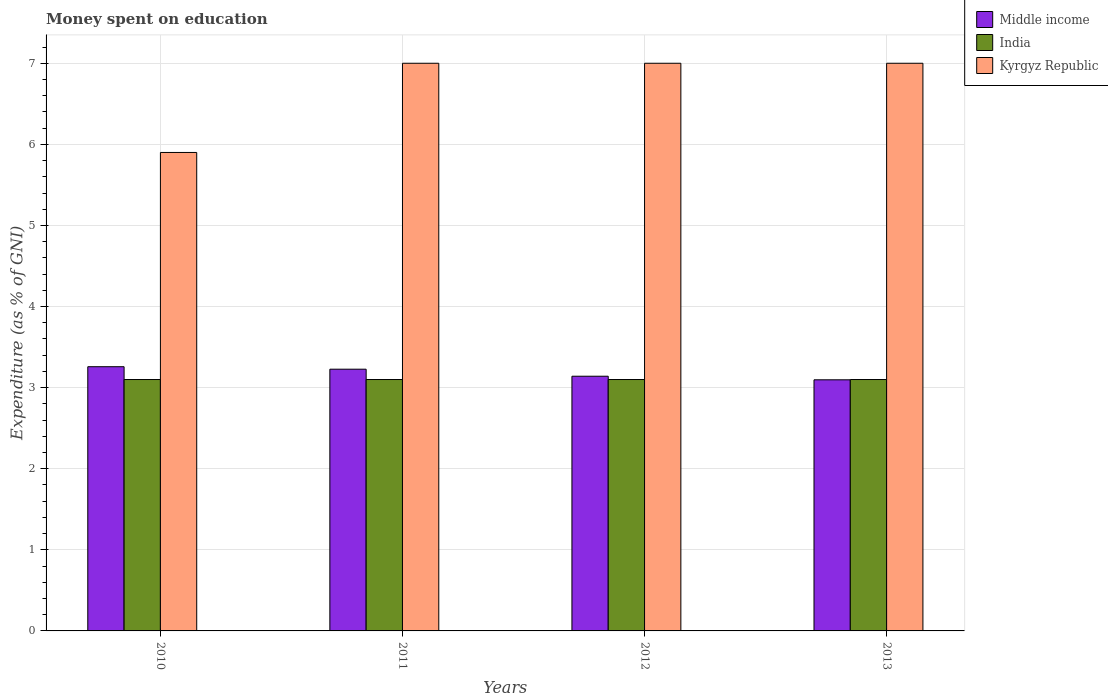How many different coloured bars are there?
Make the answer very short. 3. How many groups of bars are there?
Offer a terse response. 4. How many bars are there on the 1st tick from the right?
Ensure brevity in your answer.  3. In how many cases, is the number of bars for a given year not equal to the number of legend labels?
Offer a very short reply. 0. What is the amount of money spent on education in Middle income in 2010?
Give a very brief answer. 3.26. Across all years, what is the maximum amount of money spent on education in Middle income?
Give a very brief answer. 3.26. In which year was the amount of money spent on education in Kyrgyz Republic maximum?
Offer a very short reply. 2011. What is the total amount of money spent on education in Kyrgyz Republic in the graph?
Make the answer very short. 26.9. What is the difference between the amount of money spent on education in Middle income in 2012 and the amount of money spent on education in Kyrgyz Republic in 2013?
Keep it short and to the point. -3.86. What is the average amount of money spent on education in Middle income per year?
Provide a succinct answer. 3.18. In the year 2013, what is the difference between the amount of money spent on education in India and amount of money spent on education in Kyrgyz Republic?
Your response must be concise. -3.9. In how many years, is the amount of money spent on education in Middle income greater than 1.6 %?
Keep it short and to the point. 4. What is the ratio of the amount of money spent on education in Kyrgyz Republic in 2010 to that in 2013?
Provide a short and direct response. 0.84. What is the difference between the highest and the second highest amount of money spent on education in Kyrgyz Republic?
Keep it short and to the point. 0. What is the difference between the highest and the lowest amount of money spent on education in India?
Your answer should be very brief. 0. In how many years, is the amount of money spent on education in India greater than the average amount of money spent on education in India taken over all years?
Give a very brief answer. 0. What does the 2nd bar from the right in 2013 represents?
Make the answer very short. India. Is it the case that in every year, the sum of the amount of money spent on education in India and amount of money spent on education in Kyrgyz Republic is greater than the amount of money spent on education in Middle income?
Your answer should be very brief. Yes. How many bars are there?
Your answer should be very brief. 12. How many years are there in the graph?
Make the answer very short. 4. What is the difference between two consecutive major ticks on the Y-axis?
Offer a terse response. 1. Does the graph contain grids?
Your answer should be very brief. Yes. What is the title of the graph?
Offer a very short reply. Money spent on education. What is the label or title of the Y-axis?
Give a very brief answer. Expenditure (as % of GNI). What is the Expenditure (as % of GNI) in Middle income in 2010?
Your answer should be compact. 3.26. What is the Expenditure (as % of GNI) in Middle income in 2011?
Give a very brief answer. 3.23. What is the Expenditure (as % of GNI) in Kyrgyz Republic in 2011?
Provide a short and direct response. 7. What is the Expenditure (as % of GNI) of Middle income in 2012?
Your response must be concise. 3.14. What is the Expenditure (as % of GNI) of India in 2012?
Your response must be concise. 3.1. What is the Expenditure (as % of GNI) of Kyrgyz Republic in 2012?
Your answer should be compact. 7. What is the Expenditure (as % of GNI) in Middle income in 2013?
Keep it short and to the point. 3.1. What is the Expenditure (as % of GNI) of India in 2013?
Offer a very short reply. 3.1. What is the Expenditure (as % of GNI) of Kyrgyz Republic in 2013?
Provide a succinct answer. 7. Across all years, what is the maximum Expenditure (as % of GNI) in Middle income?
Your answer should be very brief. 3.26. Across all years, what is the maximum Expenditure (as % of GNI) of India?
Offer a terse response. 3.1. Across all years, what is the maximum Expenditure (as % of GNI) in Kyrgyz Republic?
Your response must be concise. 7. Across all years, what is the minimum Expenditure (as % of GNI) in Middle income?
Your response must be concise. 3.1. Across all years, what is the minimum Expenditure (as % of GNI) in Kyrgyz Republic?
Ensure brevity in your answer.  5.9. What is the total Expenditure (as % of GNI) in Middle income in the graph?
Ensure brevity in your answer.  12.72. What is the total Expenditure (as % of GNI) in Kyrgyz Republic in the graph?
Keep it short and to the point. 26.9. What is the difference between the Expenditure (as % of GNI) of Middle income in 2010 and that in 2011?
Provide a short and direct response. 0.03. What is the difference between the Expenditure (as % of GNI) in Middle income in 2010 and that in 2012?
Your answer should be very brief. 0.12. What is the difference between the Expenditure (as % of GNI) in India in 2010 and that in 2012?
Keep it short and to the point. 0. What is the difference between the Expenditure (as % of GNI) of Middle income in 2010 and that in 2013?
Provide a short and direct response. 0.16. What is the difference between the Expenditure (as % of GNI) of India in 2010 and that in 2013?
Give a very brief answer. 0. What is the difference between the Expenditure (as % of GNI) of Middle income in 2011 and that in 2012?
Give a very brief answer. 0.09. What is the difference between the Expenditure (as % of GNI) in India in 2011 and that in 2012?
Offer a terse response. 0. What is the difference between the Expenditure (as % of GNI) of Middle income in 2011 and that in 2013?
Your answer should be very brief. 0.13. What is the difference between the Expenditure (as % of GNI) of India in 2011 and that in 2013?
Offer a terse response. 0. What is the difference between the Expenditure (as % of GNI) of Middle income in 2012 and that in 2013?
Your answer should be very brief. 0.04. What is the difference between the Expenditure (as % of GNI) of India in 2012 and that in 2013?
Make the answer very short. 0. What is the difference between the Expenditure (as % of GNI) in Kyrgyz Republic in 2012 and that in 2013?
Offer a very short reply. 0. What is the difference between the Expenditure (as % of GNI) in Middle income in 2010 and the Expenditure (as % of GNI) in India in 2011?
Offer a terse response. 0.16. What is the difference between the Expenditure (as % of GNI) in Middle income in 2010 and the Expenditure (as % of GNI) in Kyrgyz Republic in 2011?
Your answer should be very brief. -3.74. What is the difference between the Expenditure (as % of GNI) in India in 2010 and the Expenditure (as % of GNI) in Kyrgyz Republic in 2011?
Your answer should be very brief. -3.9. What is the difference between the Expenditure (as % of GNI) of Middle income in 2010 and the Expenditure (as % of GNI) of India in 2012?
Give a very brief answer. 0.16. What is the difference between the Expenditure (as % of GNI) in Middle income in 2010 and the Expenditure (as % of GNI) in Kyrgyz Republic in 2012?
Offer a terse response. -3.74. What is the difference between the Expenditure (as % of GNI) of India in 2010 and the Expenditure (as % of GNI) of Kyrgyz Republic in 2012?
Provide a succinct answer. -3.9. What is the difference between the Expenditure (as % of GNI) of Middle income in 2010 and the Expenditure (as % of GNI) of India in 2013?
Offer a terse response. 0.16. What is the difference between the Expenditure (as % of GNI) in Middle income in 2010 and the Expenditure (as % of GNI) in Kyrgyz Republic in 2013?
Give a very brief answer. -3.74. What is the difference between the Expenditure (as % of GNI) of Middle income in 2011 and the Expenditure (as % of GNI) of India in 2012?
Your answer should be very brief. 0.13. What is the difference between the Expenditure (as % of GNI) in Middle income in 2011 and the Expenditure (as % of GNI) in Kyrgyz Republic in 2012?
Offer a very short reply. -3.77. What is the difference between the Expenditure (as % of GNI) of India in 2011 and the Expenditure (as % of GNI) of Kyrgyz Republic in 2012?
Offer a terse response. -3.9. What is the difference between the Expenditure (as % of GNI) of Middle income in 2011 and the Expenditure (as % of GNI) of India in 2013?
Provide a succinct answer. 0.13. What is the difference between the Expenditure (as % of GNI) of Middle income in 2011 and the Expenditure (as % of GNI) of Kyrgyz Republic in 2013?
Offer a very short reply. -3.77. What is the difference between the Expenditure (as % of GNI) in Middle income in 2012 and the Expenditure (as % of GNI) in India in 2013?
Keep it short and to the point. 0.04. What is the difference between the Expenditure (as % of GNI) of Middle income in 2012 and the Expenditure (as % of GNI) of Kyrgyz Republic in 2013?
Make the answer very short. -3.86. What is the difference between the Expenditure (as % of GNI) in India in 2012 and the Expenditure (as % of GNI) in Kyrgyz Republic in 2013?
Your response must be concise. -3.9. What is the average Expenditure (as % of GNI) in Middle income per year?
Offer a terse response. 3.18. What is the average Expenditure (as % of GNI) of India per year?
Provide a short and direct response. 3.1. What is the average Expenditure (as % of GNI) in Kyrgyz Republic per year?
Ensure brevity in your answer.  6.72. In the year 2010, what is the difference between the Expenditure (as % of GNI) of Middle income and Expenditure (as % of GNI) of India?
Provide a succinct answer. 0.16. In the year 2010, what is the difference between the Expenditure (as % of GNI) in Middle income and Expenditure (as % of GNI) in Kyrgyz Republic?
Give a very brief answer. -2.64. In the year 2011, what is the difference between the Expenditure (as % of GNI) of Middle income and Expenditure (as % of GNI) of India?
Your response must be concise. 0.13. In the year 2011, what is the difference between the Expenditure (as % of GNI) of Middle income and Expenditure (as % of GNI) of Kyrgyz Republic?
Make the answer very short. -3.77. In the year 2012, what is the difference between the Expenditure (as % of GNI) in Middle income and Expenditure (as % of GNI) in India?
Your response must be concise. 0.04. In the year 2012, what is the difference between the Expenditure (as % of GNI) in Middle income and Expenditure (as % of GNI) in Kyrgyz Republic?
Provide a succinct answer. -3.86. In the year 2013, what is the difference between the Expenditure (as % of GNI) of Middle income and Expenditure (as % of GNI) of India?
Provide a short and direct response. -0. In the year 2013, what is the difference between the Expenditure (as % of GNI) in Middle income and Expenditure (as % of GNI) in Kyrgyz Republic?
Make the answer very short. -3.9. In the year 2013, what is the difference between the Expenditure (as % of GNI) of India and Expenditure (as % of GNI) of Kyrgyz Republic?
Your answer should be very brief. -3.9. What is the ratio of the Expenditure (as % of GNI) of Middle income in 2010 to that in 2011?
Give a very brief answer. 1.01. What is the ratio of the Expenditure (as % of GNI) of Kyrgyz Republic in 2010 to that in 2011?
Your response must be concise. 0.84. What is the ratio of the Expenditure (as % of GNI) of Middle income in 2010 to that in 2012?
Offer a very short reply. 1.04. What is the ratio of the Expenditure (as % of GNI) of India in 2010 to that in 2012?
Your answer should be very brief. 1. What is the ratio of the Expenditure (as % of GNI) in Kyrgyz Republic in 2010 to that in 2012?
Give a very brief answer. 0.84. What is the ratio of the Expenditure (as % of GNI) of Middle income in 2010 to that in 2013?
Offer a very short reply. 1.05. What is the ratio of the Expenditure (as % of GNI) of India in 2010 to that in 2013?
Your answer should be very brief. 1. What is the ratio of the Expenditure (as % of GNI) in Kyrgyz Republic in 2010 to that in 2013?
Provide a short and direct response. 0.84. What is the ratio of the Expenditure (as % of GNI) in Middle income in 2011 to that in 2012?
Your answer should be very brief. 1.03. What is the ratio of the Expenditure (as % of GNI) in Middle income in 2011 to that in 2013?
Offer a very short reply. 1.04. What is the ratio of the Expenditure (as % of GNI) of India in 2011 to that in 2013?
Your answer should be compact. 1. What is the ratio of the Expenditure (as % of GNI) in Middle income in 2012 to that in 2013?
Provide a short and direct response. 1.01. What is the difference between the highest and the second highest Expenditure (as % of GNI) of Middle income?
Ensure brevity in your answer.  0.03. What is the difference between the highest and the second highest Expenditure (as % of GNI) of Kyrgyz Republic?
Your answer should be very brief. 0. What is the difference between the highest and the lowest Expenditure (as % of GNI) of Middle income?
Your answer should be very brief. 0.16. What is the difference between the highest and the lowest Expenditure (as % of GNI) in India?
Make the answer very short. 0. 